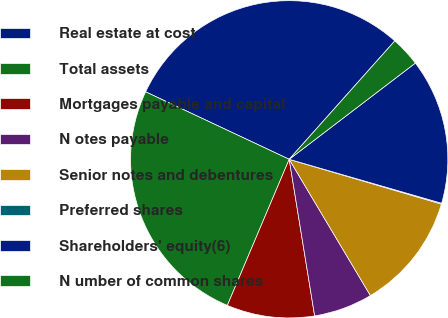<chart> <loc_0><loc_0><loc_500><loc_500><pie_chart><fcel>Real estate at cost<fcel>Total assets<fcel>Mortgages payable and capital<fcel>N otes payable<fcel>Senior notes and debentures<fcel>Preferred shares<fcel>Shareholders' equity(6)<fcel>N umber of common shares<nl><fcel>29.6%<fcel>25.62%<fcel>8.94%<fcel>5.99%<fcel>11.89%<fcel>0.09%<fcel>14.84%<fcel>3.04%<nl></chart> 